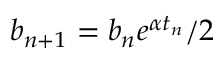Convert formula to latex. <formula><loc_0><loc_0><loc_500><loc_500>b _ { n + 1 } = b _ { n } e ^ { \alpha t _ { n } } / 2</formula> 